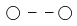<formula> <loc_0><loc_0><loc_500><loc_500>\bigcirc \, - \, - \, \bigcirc</formula> 